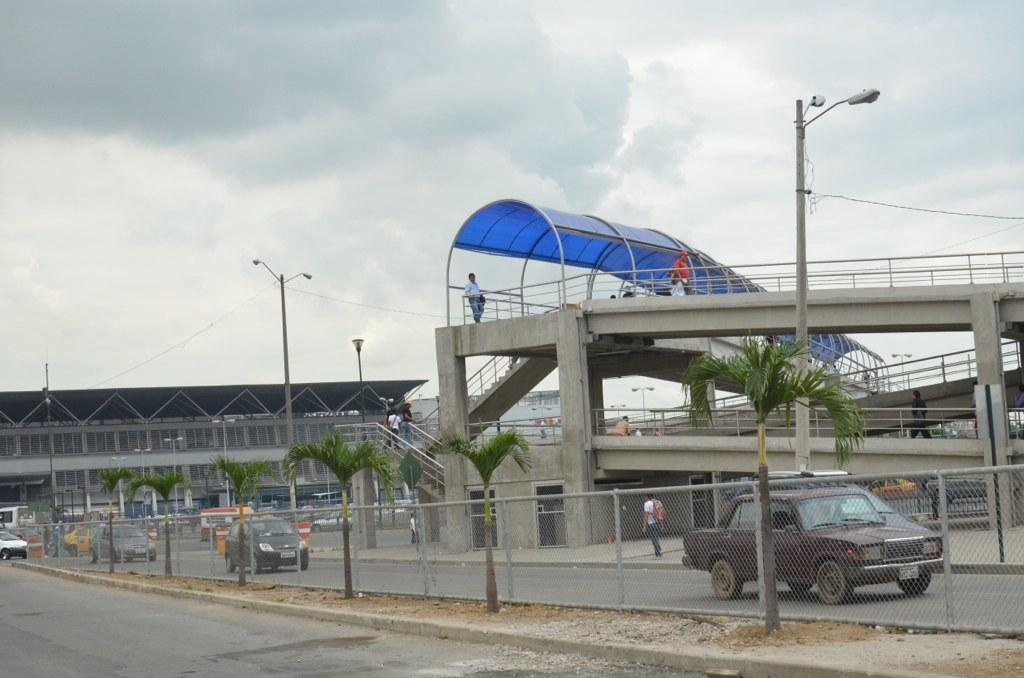What types of vehicles can be seen in the image? There are vehicles in the image, but the specific types cannot be determined from the provided facts. What is the mesh used for in the image? The purpose of the mesh in the image cannot be determined from the provided facts. What type of vegetation is present in the image? There are trees in the image. What type of infrastructure is present in the image? There are roads, light poles, sheds, stairs, railings, and pillars in the image. Are there any people in the image? Yes, there are people in the image. What is visible in the background of the image? The sky is visible in the background of the image. Where is the basketball court located in the image? There is no basketball court present in the image. What type of cake is being served to the people in the image? There is no cake present in the image. What is the purpose of the pipe visible in the image? There is no pipe present in the image. 